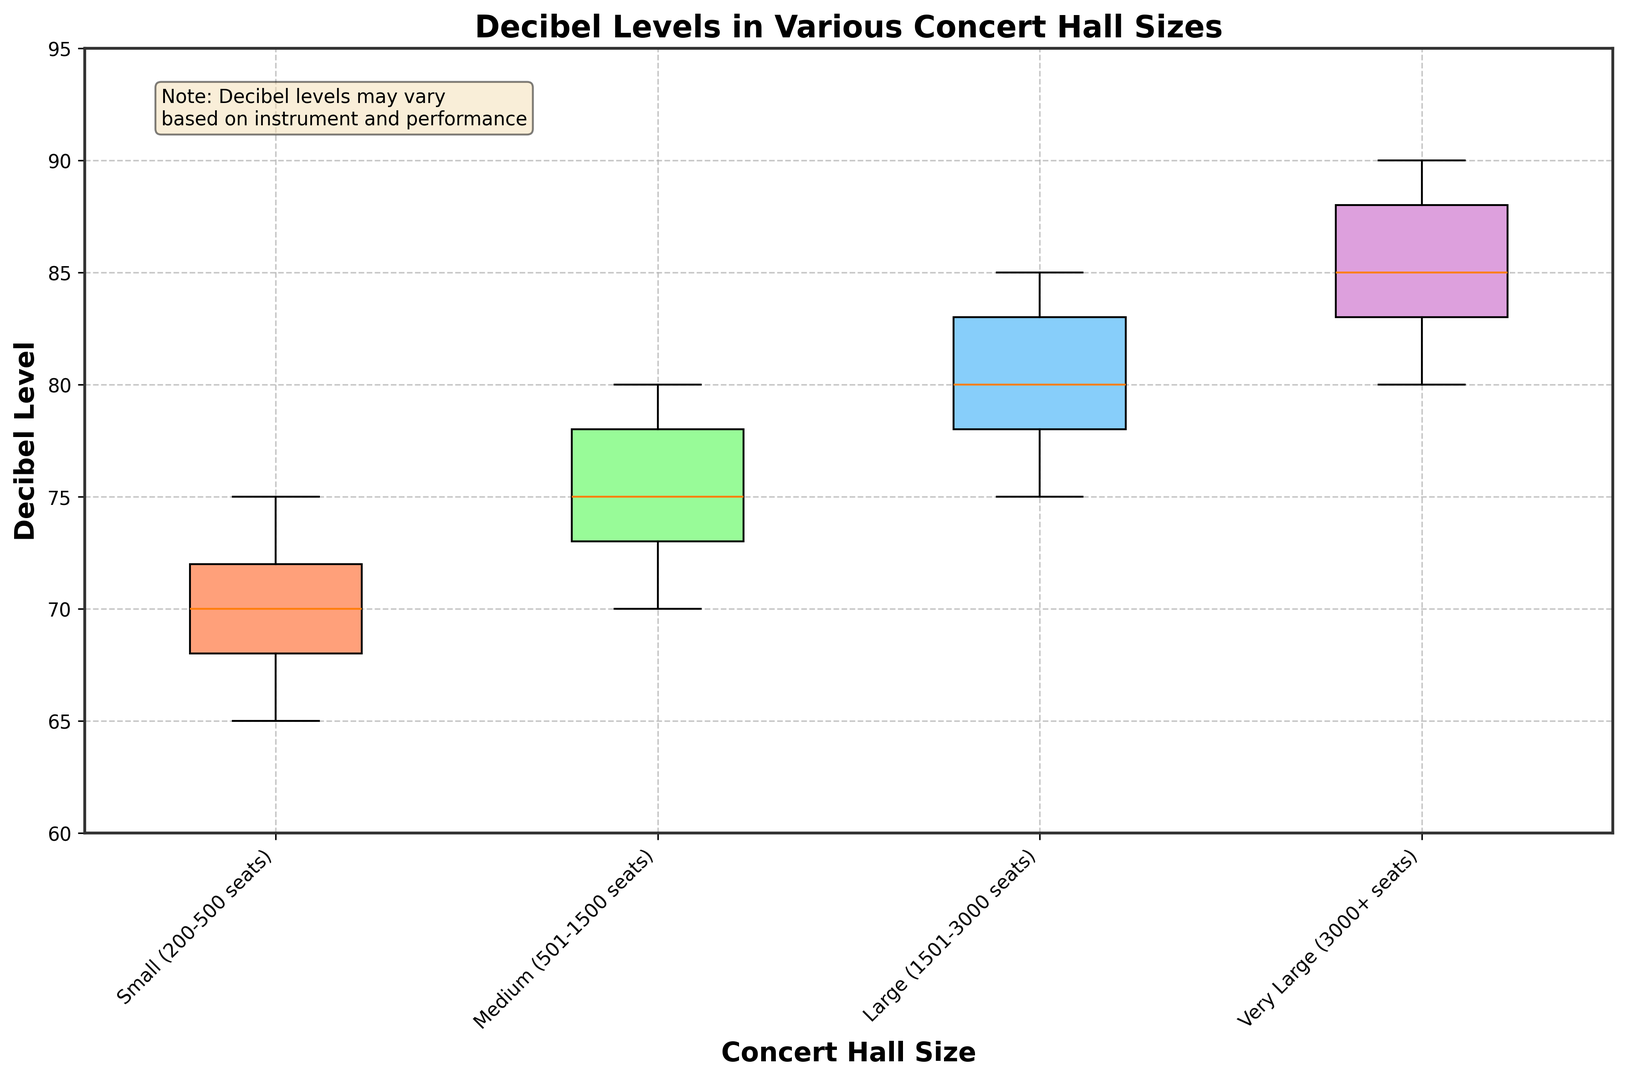Which concert hall size has the highest median decibel level? By observing the box plots, the line inside each box represents the median decibel level. The Very Large concert hall (3000+ seats) has the highest median decibel level, where the median line seems to be around 85 dB.
Answer: Very Large (3000+ seats) What is the interquartile range (IQR) of decibel levels for the Large concert hall size? The IQR is the difference between the upper quartile (75th percentile) and lower quartile (25th percentile). For the Large (1501-3000 seats) concert hall, the lower quartile is around 77 dB and the upper quartile is around 83 dB, so the IQR is 83 - 77 = 6 dB.
Answer: 6 dB Compare the range of decibel levels in Small and Medium concert halls. Which one is larger? The range is the difference between the maximum and minimum values. For Small (200-500 seats) concert halls, the range is 75 dB - 65 dB = 10 dB. For Medium (501-1500 seats) concert halls, the range is 80 dB - 70 dB = 10 dB. Both have the same range.
Answer: Equal Are there any outliers in the decibel levels for Very Large concert halls? Outliers are usually indicated by points outside the whiskers in a box plot. For Very Large (3000+ seats) concert halls, there are no points outside the whiskers, so there are no outliers.
Answer: No Between which two concert hall sizes is the increase in median decibel level most pronounced? Compare the medians marked by the lines inside the boxes. The increase in median decibel level from Large (1501-3000 seats) to Very Large (3000+ seats) is the most pronounced, with the median increasing from around 80 dB to 85 dB.
Answer: From Large (1501-3000 seats) to Very Large (3000+ seats) What is the median decibel level for Medium-sized concert halls? The median is indicated by the line inside the box for Medium (501-1500 seats) concert halls. The line is at 75 dB.
Answer: 75 dB Which concert hall size has the lowest minimum decibel level? The minimum decibel level is indicated by the bottom whisker of each box plot. The Small (200-500 seats) concert hall has the lowest minimum decibel level of 65 dB.
Answer: Small (200-500 seats) How does the variability of decibel levels in Small concert halls compare to Very Large concert halls? Variability can be inferred by the length of the box and whiskers. Small (200-500 seats) concert halls have a box spanning 68 dB to 72 dB and whiskers spanning 65 dB to 75 dB, indicating more compact variability compared to Very Large (3000+ seats) concert halls, where the range is wider.
Answer: Smaller Is the interquartile range (IQR) for Medium concert halls less than or greater than that for Large concert halls? Compute the IQR for both. For Medium, the IQR is 78 dB - 73 dB = 5 dB. For Large, the IQR is 83 dB - 77 dB = 6 dB. Therefore, the IQR for Medium is less than that for Large concert halls.
Answer: Less 